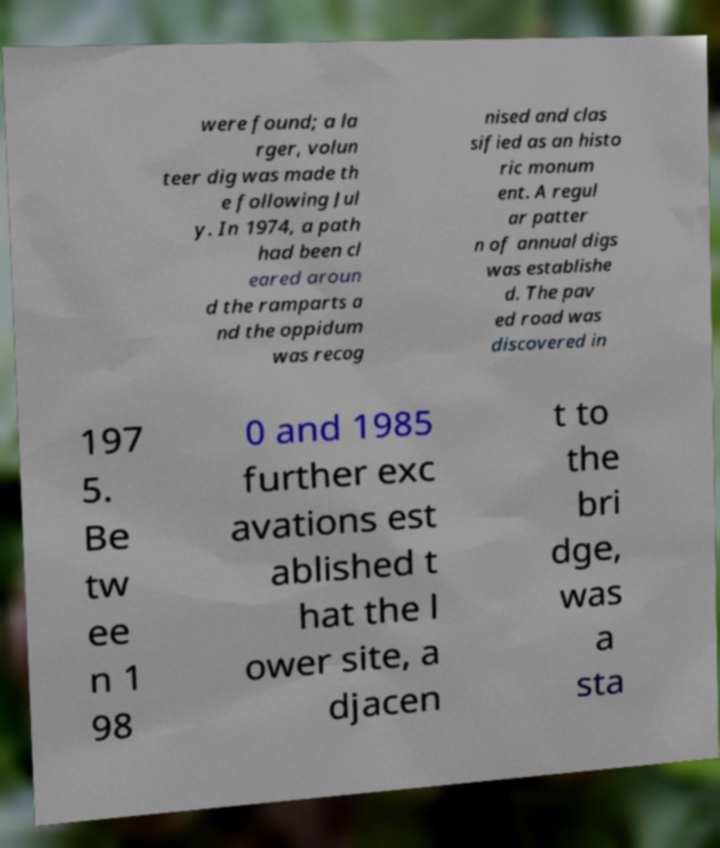Please identify and transcribe the text found in this image. were found; a la rger, volun teer dig was made th e following Jul y. In 1974, a path had been cl eared aroun d the ramparts a nd the oppidum was recog nised and clas sified as an histo ric monum ent. A regul ar patter n of annual digs was establishe d. The pav ed road was discovered in 197 5. Be tw ee n 1 98 0 and 1985 further exc avations est ablished t hat the l ower site, a djacen t to the bri dge, was a sta 